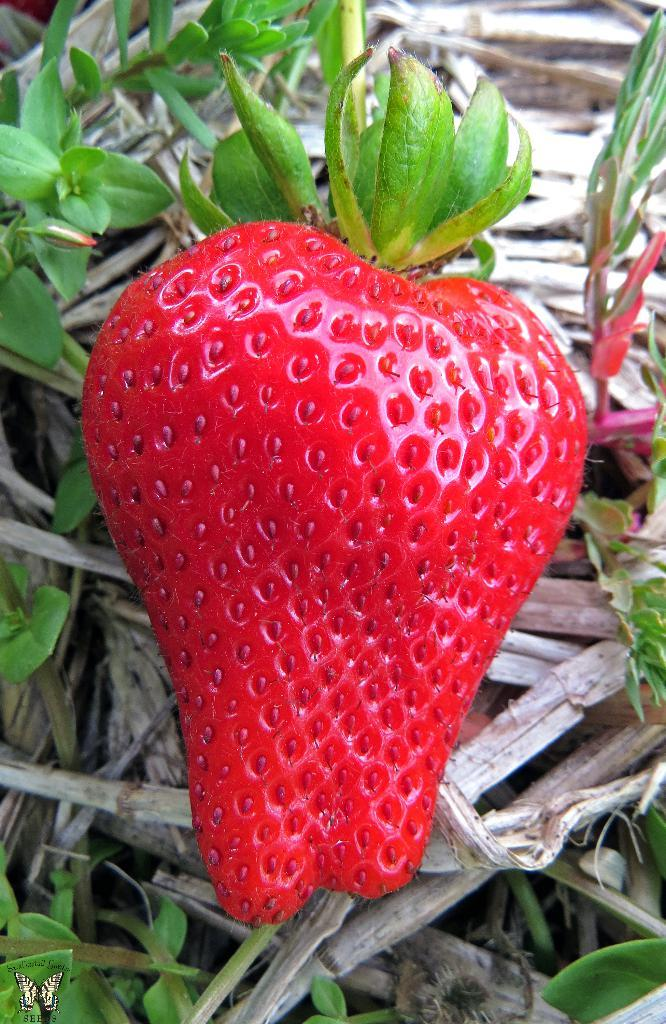What type of fruit is present in the image? There is a strawberry in the image. What type of material can be seen in the background of the image? Wood is visible in the background of the image. What type of vegetation is present in the background of the image? There are plants in the background of the image. Who is the creator of the structure visible in the image? There is no structure present in the image, so it is not possible to determine who the creator might be. 